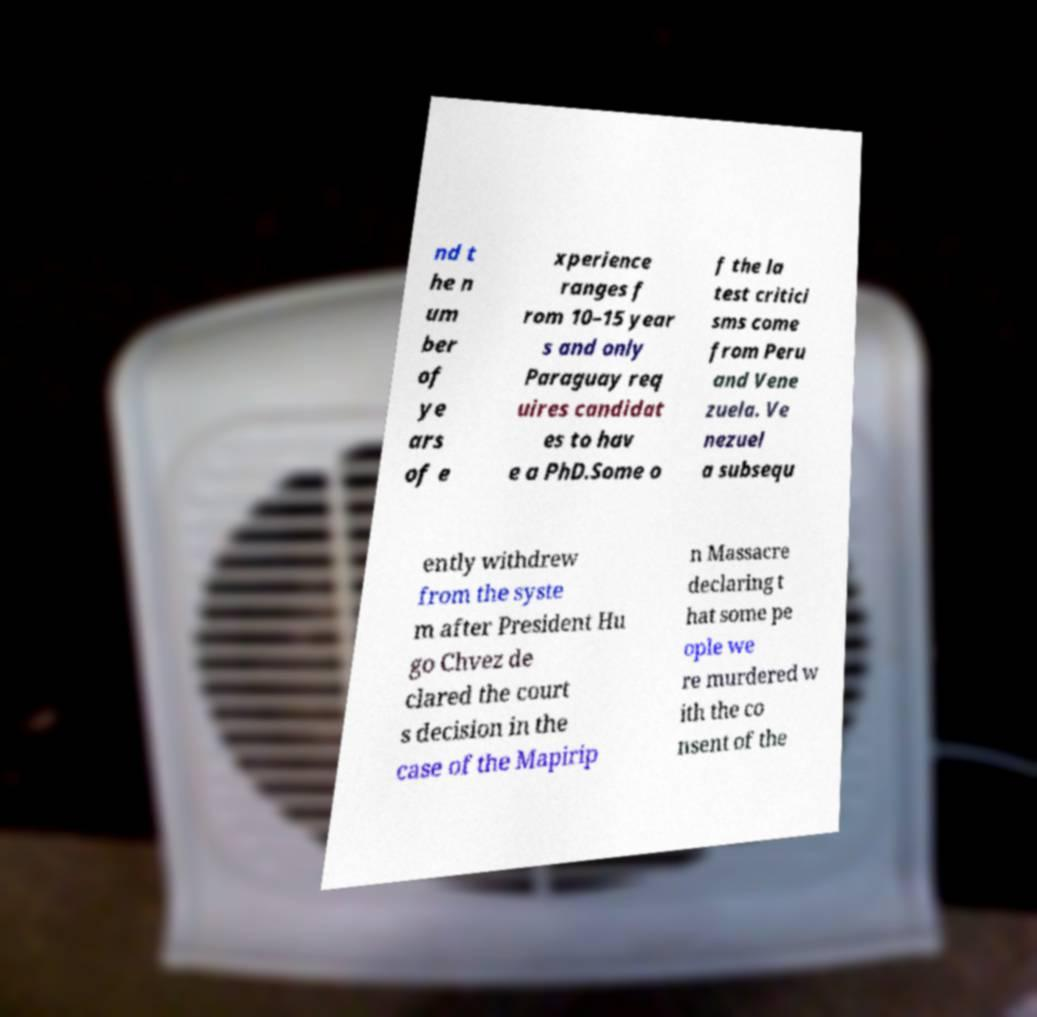There's text embedded in this image that I need extracted. Can you transcribe it verbatim? nd t he n um ber of ye ars of e xperience ranges f rom 10–15 year s and only Paraguay req uires candidat es to hav e a PhD.Some o f the la test critici sms come from Peru and Vene zuela. Ve nezuel a subsequ ently withdrew from the syste m after President Hu go Chvez de clared the court s decision in the case of the Mapirip n Massacre declaring t hat some pe ople we re murdered w ith the co nsent of the 